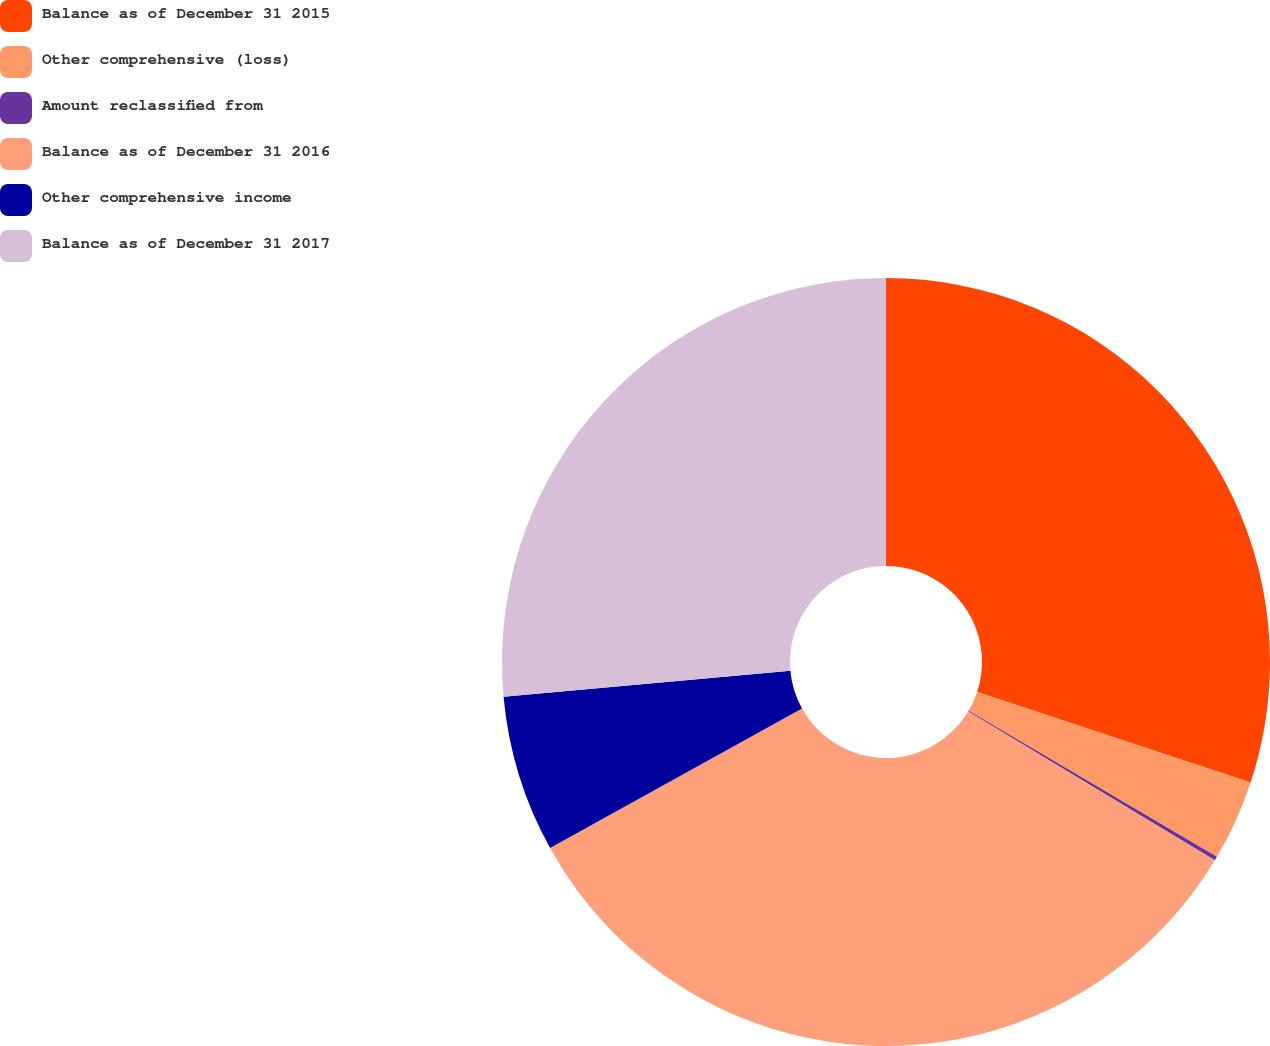Convert chart to OTSL. <chart><loc_0><loc_0><loc_500><loc_500><pie_chart><fcel>Balance as of December 31 2015<fcel>Other comprehensive (loss)<fcel>Amount reclassified from<fcel>Balance as of December 31 2016<fcel>Other comprehensive income<fcel>Balance as of December 31 2017<nl><fcel>30.08%<fcel>3.39%<fcel>0.17%<fcel>33.31%<fcel>6.61%<fcel>26.44%<nl></chart> 